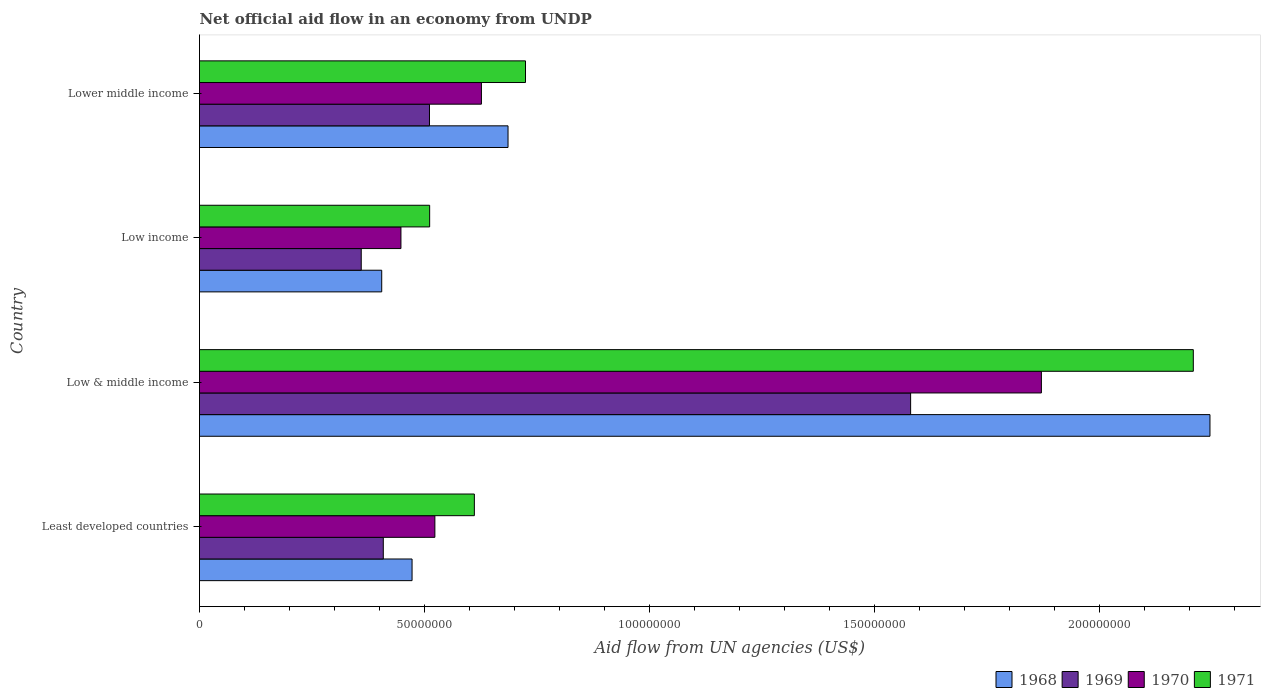How many different coloured bars are there?
Your response must be concise. 4. How many groups of bars are there?
Ensure brevity in your answer.  4. Are the number of bars on each tick of the Y-axis equal?
Ensure brevity in your answer.  Yes. How many bars are there on the 4th tick from the top?
Provide a short and direct response. 4. What is the label of the 1st group of bars from the top?
Offer a terse response. Lower middle income. What is the net official aid flow in 1969 in Lower middle income?
Offer a very short reply. 5.11e+07. Across all countries, what is the maximum net official aid flow in 1971?
Make the answer very short. 2.21e+08. Across all countries, what is the minimum net official aid flow in 1968?
Offer a terse response. 4.05e+07. In which country was the net official aid flow in 1968 maximum?
Provide a succinct answer. Low & middle income. What is the total net official aid flow in 1970 in the graph?
Your answer should be compact. 3.47e+08. What is the difference between the net official aid flow in 1969 in Least developed countries and that in Low & middle income?
Provide a short and direct response. -1.17e+08. What is the difference between the net official aid flow in 1969 in Lower middle income and the net official aid flow in 1968 in Least developed countries?
Provide a short and direct response. 3.87e+06. What is the average net official aid flow in 1969 per country?
Provide a succinct answer. 7.15e+07. What is the difference between the net official aid flow in 1968 and net official aid flow in 1971 in Low income?
Your answer should be very brief. -1.06e+07. What is the ratio of the net official aid flow in 1968 in Least developed countries to that in Low income?
Make the answer very short. 1.17. Is the net official aid flow in 1969 in Least developed countries less than that in Low & middle income?
Give a very brief answer. Yes. Is the difference between the net official aid flow in 1968 in Low income and Lower middle income greater than the difference between the net official aid flow in 1971 in Low income and Lower middle income?
Your response must be concise. No. What is the difference between the highest and the second highest net official aid flow in 1968?
Give a very brief answer. 1.56e+08. What is the difference between the highest and the lowest net official aid flow in 1970?
Provide a succinct answer. 1.42e+08. In how many countries, is the net official aid flow in 1970 greater than the average net official aid flow in 1970 taken over all countries?
Offer a very short reply. 1. Is the sum of the net official aid flow in 1968 in Low income and Lower middle income greater than the maximum net official aid flow in 1970 across all countries?
Provide a succinct answer. No. What does the 1st bar from the top in Least developed countries represents?
Ensure brevity in your answer.  1971. What does the 1st bar from the bottom in Low income represents?
Ensure brevity in your answer.  1968. Is it the case that in every country, the sum of the net official aid flow in 1968 and net official aid flow in 1969 is greater than the net official aid flow in 1971?
Offer a very short reply. Yes. Are all the bars in the graph horizontal?
Give a very brief answer. Yes. How many countries are there in the graph?
Your answer should be very brief. 4. What is the difference between two consecutive major ticks on the X-axis?
Provide a succinct answer. 5.00e+07. Does the graph contain grids?
Give a very brief answer. No. How are the legend labels stacked?
Make the answer very short. Horizontal. What is the title of the graph?
Your answer should be very brief. Net official aid flow in an economy from UNDP. Does "2014" appear as one of the legend labels in the graph?
Ensure brevity in your answer.  No. What is the label or title of the X-axis?
Offer a terse response. Aid flow from UN agencies (US$). What is the label or title of the Y-axis?
Your response must be concise. Country. What is the Aid flow from UN agencies (US$) in 1968 in Least developed countries?
Offer a terse response. 4.72e+07. What is the Aid flow from UN agencies (US$) of 1969 in Least developed countries?
Ensure brevity in your answer.  4.08e+07. What is the Aid flow from UN agencies (US$) in 1970 in Least developed countries?
Offer a terse response. 5.23e+07. What is the Aid flow from UN agencies (US$) of 1971 in Least developed countries?
Your answer should be compact. 6.11e+07. What is the Aid flow from UN agencies (US$) in 1968 in Low & middle income?
Offer a terse response. 2.24e+08. What is the Aid flow from UN agencies (US$) of 1969 in Low & middle income?
Ensure brevity in your answer.  1.58e+08. What is the Aid flow from UN agencies (US$) of 1970 in Low & middle income?
Provide a short and direct response. 1.87e+08. What is the Aid flow from UN agencies (US$) of 1971 in Low & middle income?
Give a very brief answer. 2.21e+08. What is the Aid flow from UN agencies (US$) in 1968 in Low income?
Provide a short and direct response. 4.05e+07. What is the Aid flow from UN agencies (US$) in 1969 in Low income?
Offer a terse response. 3.59e+07. What is the Aid flow from UN agencies (US$) of 1970 in Low income?
Provide a succinct answer. 4.48e+07. What is the Aid flow from UN agencies (US$) of 1971 in Low income?
Your answer should be compact. 5.11e+07. What is the Aid flow from UN agencies (US$) in 1968 in Lower middle income?
Give a very brief answer. 6.85e+07. What is the Aid flow from UN agencies (US$) in 1969 in Lower middle income?
Give a very brief answer. 5.11e+07. What is the Aid flow from UN agencies (US$) in 1970 in Lower middle income?
Give a very brief answer. 6.26e+07. What is the Aid flow from UN agencies (US$) in 1971 in Lower middle income?
Your answer should be compact. 7.24e+07. Across all countries, what is the maximum Aid flow from UN agencies (US$) of 1968?
Provide a succinct answer. 2.24e+08. Across all countries, what is the maximum Aid flow from UN agencies (US$) of 1969?
Your answer should be very brief. 1.58e+08. Across all countries, what is the maximum Aid flow from UN agencies (US$) in 1970?
Offer a terse response. 1.87e+08. Across all countries, what is the maximum Aid flow from UN agencies (US$) of 1971?
Your answer should be very brief. 2.21e+08. Across all countries, what is the minimum Aid flow from UN agencies (US$) of 1968?
Make the answer very short. 4.05e+07. Across all countries, what is the minimum Aid flow from UN agencies (US$) of 1969?
Offer a terse response. 3.59e+07. Across all countries, what is the minimum Aid flow from UN agencies (US$) of 1970?
Your answer should be very brief. 4.48e+07. Across all countries, what is the minimum Aid flow from UN agencies (US$) of 1971?
Make the answer very short. 5.11e+07. What is the total Aid flow from UN agencies (US$) of 1968 in the graph?
Provide a succinct answer. 3.81e+08. What is the total Aid flow from UN agencies (US$) of 1969 in the graph?
Ensure brevity in your answer.  2.86e+08. What is the total Aid flow from UN agencies (US$) in 1970 in the graph?
Provide a succinct answer. 3.47e+08. What is the total Aid flow from UN agencies (US$) of 1971 in the graph?
Your answer should be compact. 4.05e+08. What is the difference between the Aid flow from UN agencies (US$) in 1968 in Least developed countries and that in Low & middle income?
Make the answer very short. -1.77e+08. What is the difference between the Aid flow from UN agencies (US$) of 1969 in Least developed countries and that in Low & middle income?
Your response must be concise. -1.17e+08. What is the difference between the Aid flow from UN agencies (US$) in 1970 in Least developed countries and that in Low & middle income?
Give a very brief answer. -1.35e+08. What is the difference between the Aid flow from UN agencies (US$) of 1971 in Least developed countries and that in Low & middle income?
Provide a short and direct response. -1.60e+08. What is the difference between the Aid flow from UN agencies (US$) of 1968 in Least developed countries and that in Low income?
Offer a terse response. 6.74e+06. What is the difference between the Aid flow from UN agencies (US$) of 1969 in Least developed countries and that in Low income?
Make the answer very short. 4.90e+06. What is the difference between the Aid flow from UN agencies (US$) of 1970 in Least developed countries and that in Low income?
Provide a succinct answer. 7.54e+06. What is the difference between the Aid flow from UN agencies (US$) of 1971 in Least developed countries and that in Low income?
Offer a terse response. 9.93e+06. What is the difference between the Aid flow from UN agencies (US$) of 1968 in Least developed countries and that in Lower middle income?
Provide a short and direct response. -2.13e+07. What is the difference between the Aid flow from UN agencies (US$) in 1969 in Least developed countries and that in Lower middle income?
Give a very brief answer. -1.03e+07. What is the difference between the Aid flow from UN agencies (US$) in 1970 in Least developed countries and that in Lower middle income?
Your answer should be very brief. -1.03e+07. What is the difference between the Aid flow from UN agencies (US$) of 1971 in Least developed countries and that in Lower middle income?
Offer a very short reply. -1.14e+07. What is the difference between the Aid flow from UN agencies (US$) in 1968 in Low & middle income and that in Low income?
Provide a short and direct response. 1.84e+08. What is the difference between the Aid flow from UN agencies (US$) of 1969 in Low & middle income and that in Low income?
Your response must be concise. 1.22e+08. What is the difference between the Aid flow from UN agencies (US$) of 1970 in Low & middle income and that in Low income?
Provide a succinct answer. 1.42e+08. What is the difference between the Aid flow from UN agencies (US$) in 1971 in Low & middle income and that in Low income?
Your response must be concise. 1.70e+08. What is the difference between the Aid flow from UN agencies (US$) in 1968 in Low & middle income and that in Lower middle income?
Offer a terse response. 1.56e+08. What is the difference between the Aid flow from UN agencies (US$) of 1969 in Low & middle income and that in Lower middle income?
Provide a succinct answer. 1.07e+08. What is the difference between the Aid flow from UN agencies (US$) in 1970 in Low & middle income and that in Lower middle income?
Your response must be concise. 1.24e+08. What is the difference between the Aid flow from UN agencies (US$) of 1971 in Low & middle income and that in Lower middle income?
Keep it short and to the point. 1.48e+08. What is the difference between the Aid flow from UN agencies (US$) of 1968 in Low income and that in Lower middle income?
Give a very brief answer. -2.81e+07. What is the difference between the Aid flow from UN agencies (US$) in 1969 in Low income and that in Lower middle income?
Give a very brief answer. -1.52e+07. What is the difference between the Aid flow from UN agencies (US$) in 1970 in Low income and that in Lower middle income?
Offer a terse response. -1.79e+07. What is the difference between the Aid flow from UN agencies (US$) of 1971 in Low income and that in Lower middle income?
Provide a succinct answer. -2.13e+07. What is the difference between the Aid flow from UN agencies (US$) of 1968 in Least developed countries and the Aid flow from UN agencies (US$) of 1969 in Low & middle income?
Provide a short and direct response. -1.11e+08. What is the difference between the Aid flow from UN agencies (US$) in 1968 in Least developed countries and the Aid flow from UN agencies (US$) in 1970 in Low & middle income?
Your answer should be very brief. -1.40e+08. What is the difference between the Aid flow from UN agencies (US$) in 1968 in Least developed countries and the Aid flow from UN agencies (US$) in 1971 in Low & middle income?
Your answer should be very brief. -1.74e+08. What is the difference between the Aid flow from UN agencies (US$) in 1969 in Least developed countries and the Aid flow from UN agencies (US$) in 1970 in Low & middle income?
Your answer should be compact. -1.46e+08. What is the difference between the Aid flow from UN agencies (US$) in 1969 in Least developed countries and the Aid flow from UN agencies (US$) in 1971 in Low & middle income?
Give a very brief answer. -1.80e+08. What is the difference between the Aid flow from UN agencies (US$) in 1970 in Least developed countries and the Aid flow from UN agencies (US$) in 1971 in Low & middle income?
Keep it short and to the point. -1.68e+08. What is the difference between the Aid flow from UN agencies (US$) of 1968 in Least developed countries and the Aid flow from UN agencies (US$) of 1969 in Low income?
Provide a short and direct response. 1.13e+07. What is the difference between the Aid flow from UN agencies (US$) of 1968 in Least developed countries and the Aid flow from UN agencies (US$) of 1970 in Low income?
Your answer should be compact. 2.47e+06. What is the difference between the Aid flow from UN agencies (US$) in 1968 in Least developed countries and the Aid flow from UN agencies (US$) in 1971 in Low income?
Ensure brevity in your answer.  -3.91e+06. What is the difference between the Aid flow from UN agencies (US$) in 1969 in Least developed countries and the Aid flow from UN agencies (US$) in 1970 in Low income?
Your answer should be compact. -3.92e+06. What is the difference between the Aid flow from UN agencies (US$) of 1969 in Least developed countries and the Aid flow from UN agencies (US$) of 1971 in Low income?
Offer a very short reply. -1.03e+07. What is the difference between the Aid flow from UN agencies (US$) of 1970 in Least developed countries and the Aid flow from UN agencies (US$) of 1971 in Low income?
Provide a succinct answer. 1.16e+06. What is the difference between the Aid flow from UN agencies (US$) of 1968 in Least developed countries and the Aid flow from UN agencies (US$) of 1969 in Lower middle income?
Provide a succinct answer. -3.87e+06. What is the difference between the Aid flow from UN agencies (US$) in 1968 in Least developed countries and the Aid flow from UN agencies (US$) in 1970 in Lower middle income?
Make the answer very short. -1.54e+07. What is the difference between the Aid flow from UN agencies (US$) of 1968 in Least developed countries and the Aid flow from UN agencies (US$) of 1971 in Lower middle income?
Provide a short and direct response. -2.52e+07. What is the difference between the Aid flow from UN agencies (US$) of 1969 in Least developed countries and the Aid flow from UN agencies (US$) of 1970 in Lower middle income?
Your response must be concise. -2.18e+07. What is the difference between the Aid flow from UN agencies (US$) of 1969 in Least developed countries and the Aid flow from UN agencies (US$) of 1971 in Lower middle income?
Keep it short and to the point. -3.16e+07. What is the difference between the Aid flow from UN agencies (US$) in 1970 in Least developed countries and the Aid flow from UN agencies (US$) in 1971 in Lower middle income?
Provide a succinct answer. -2.01e+07. What is the difference between the Aid flow from UN agencies (US$) of 1968 in Low & middle income and the Aid flow from UN agencies (US$) of 1969 in Low income?
Offer a very short reply. 1.89e+08. What is the difference between the Aid flow from UN agencies (US$) of 1968 in Low & middle income and the Aid flow from UN agencies (US$) of 1970 in Low income?
Provide a short and direct response. 1.80e+08. What is the difference between the Aid flow from UN agencies (US$) in 1968 in Low & middle income and the Aid flow from UN agencies (US$) in 1971 in Low income?
Provide a short and direct response. 1.73e+08. What is the difference between the Aid flow from UN agencies (US$) of 1969 in Low & middle income and the Aid flow from UN agencies (US$) of 1970 in Low income?
Keep it short and to the point. 1.13e+08. What is the difference between the Aid flow from UN agencies (US$) of 1969 in Low & middle income and the Aid flow from UN agencies (US$) of 1971 in Low income?
Provide a short and direct response. 1.07e+08. What is the difference between the Aid flow from UN agencies (US$) in 1970 in Low & middle income and the Aid flow from UN agencies (US$) in 1971 in Low income?
Give a very brief answer. 1.36e+08. What is the difference between the Aid flow from UN agencies (US$) in 1968 in Low & middle income and the Aid flow from UN agencies (US$) in 1969 in Lower middle income?
Offer a terse response. 1.73e+08. What is the difference between the Aid flow from UN agencies (US$) in 1968 in Low & middle income and the Aid flow from UN agencies (US$) in 1970 in Lower middle income?
Your answer should be very brief. 1.62e+08. What is the difference between the Aid flow from UN agencies (US$) in 1968 in Low & middle income and the Aid flow from UN agencies (US$) in 1971 in Lower middle income?
Your answer should be very brief. 1.52e+08. What is the difference between the Aid flow from UN agencies (US$) in 1969 in Low & middle income and the Aid flow from UN agencies (US$) in 1970 in Lower middle income?
Offer a terse response. 9.54e+07. What is the difference between the Aid flow from UN agencies (US$) in 1969 in Low & middle income and the Aid flow from UN agencies (US$) in 1971 in Lower middle income?
Your answer should be very brief. 8.56e+07. What is the difference between the Aid flow from UN agencies (US$) of 1970 in Low & middle income and the Aid flow from UN agencies (US$) of 1971 in Lower middle income?
Provide a short and direct response. 1.15e+08. What is the difference between the Aid flow from UN agencies (US$) in 1968 in Low income and the Aid flow from UN agencies (US$) in 1969 in Lower middle income?
Your answer should be compact. -1.06e+07. What is the difference between the Aid flow from UN agencies (US$) of 1968 in Low income and the Aid flow from UN agencies (US$) of 1970 in Lower middle income?
Keep it short and to the point. -2.22e+07. What is the difference between the Aid flow from UN agencies (US$) of 1968 in Low income and the Aid flow from UN agencies (US$) of 1971 in Lower middle income?
Offer a very short reply. -3.19e+07. What is the difference between the Aid flow from UN agencies (US$) of 1969 in Low income and the Aid flow from UN agencies (US$) of 1970 in Lower middle income?
Provide a short and direct response. -2.67e+07. What is the difference between the Aid flow from UN agencies (US$) of 1969 in Low income and the Aid flow from UN agencies (US$) of 1971 in Lower middle income?
Your response must be concise. -3.65e+07. What is the difference between the Aid flow from UN agencies (US$) of 1970 in Low income and the Aid flow from UN agencies (US$) of 1971 in Lower middle income?
Provide a short and direct response. -2.77e+07. What is the average Aid flow from UN agencies (US$) of 1968 per country?
Give a very brief answer. 9.52e+07. What is the average Aid flow from UN agencies (US$) of 1969 per country?
Provide a succinct answer. 7.15e+07. What is the average Aid flow from UN agencies (US$) in 1970 per country?
Offer a terse response. 8.67e+07. What is the average Aid flow from UN agencies (US$) of 1971 per country?
Give a very brief answer. 1.01e+08. What is the difference between the Aid flow from UN agencies (US$) in 1968 and Aid flow from UN agencies (US$) in 1969 in Least developed countries?
Offer a very short reply. 6.39e+06. What is the difference between the Aid flow from UN agencies (US$) of 1968 and Aid flow from UN agencies (US$) of 1970 in Least developed countries?
Your response must be concise. -5.07e+06. What is the difference between the Aid flow from UN agencies (US$) in 1968 and Aid flow from UN agencies (US$) in 1971 in Least developed countries?
Give a very brief answer. -1.38e+07. What is the difference between the Aid flow from UN agencies (US$) in 1969 and Aid flow from UN agencies (US$) in 1970 in Least developed countries?
Your answer should be compact. -1.15e+07. What is the difference between the Aid flow from UN agencies (US$) of 1969 and Aid flow from UN agencies (US$) of 1971 in Least developed countries?
Offer a very short reply. -2.02e+07. What is the difference between the Aid flow from UN agencies (US$) in 1970 and Aid flow from UN agencies (US$) in 1971 in Least developed countries?
Offer a very short reply. -8.77e+06. What is the difference between the Aid flow from UN agencies (US$) of 1968 and Aid flow from UN agencies (US$) of 1969 in Low & middle income?
Offer a terse response. 6.65e+07. What is the difference between the Aid flow from UN agencies (US$) in 1968 and Aid flow from UN agencies (US$) in 1970 in Low & middle income?
Offer a very short reply. 3.74e+07. What is the difference between the Aid flow from UN agencies (US$) in 1968 and Aid flow from UN agencies (US$) in 1971 in Low & middle income?
Ensure brevity in your answer.  3.70e+06. What is the difference between the Aid flow from UN agencies (US$) of 1969 and Aid flow from UN agencies (US$) of 1970 in Low & middle income?
Offer a terse response. -2.90e+07. What is the difference between the Aid flow from UN agencies (US$) of 1969 and Aid flow from UN agencies (US$) of 1971 in Low & middle income?
Give a very brief answer. -6.28e+07. What is the difference between the Aid flow from UN agencies (US$) of 1970 and Aid flow from UN agencies (US$) of 1971 in Low & middle income?
Ensure brevity in your answer.  -3.38e+07. What is the difference between the Aid flow from UN agencies (US$) of 1968 and Aid flow from UN agencies (US$) of 1969 in Low income?
Keep it short and to the point. 4.55e+06. What is the difference between the Aid flow from UN agencies (US$) in 1968 and Aid flow from UN agencies (US$) in 1970 in Low income?
Offer a terse response. -4.27e+06. What is the difference between the Aid flow from UN agencies (US$) in 1968 and Aid flow from UN agencies (US$) in 1971 in Low income?
Keep it short and to the point. -1.06e+07. What is the difference between the Aid flow from UN agencies (US$) in 1969 and Aid flow from UN agencies (US$) in 1970 in Low income?
Offer a very short reply. -8.82e+06. What is the difference between the Aid flow from UN agencies (US$) in 1969 and Aid flow from UN agencies (US$) in 1971 in Low income?
Your answer should be very brief. -1.52e+07. What is the difference between the Aid flow from UN agencies (US$) in 1970 and Aid flow from UN agencies (US$) in 1971 in Low income?
Give a very brief answer. -6.38e+06. What is the difference between the Aid flow from UN agencies (US$) in 1968 and Aid flow from UN agencies (US$) in 1969 in Lower middle income?
Ensure brevity in your answer.  1.74e+07. What is the difference between the Aid flow from UN agencies (US$) of 1968 and Aid flow from UN agencies (US$) of 1970 in Lower middle income?
Ensure brevity in your answer.  5.91e+06. What is the difference between the Aid flow from UN agencies (US$) in 1968 and Aid flow from UN agencies (US$) in 1971 in Lower middle income?
Your response must be concise. -3.88e+06. What is the difference between the Aid flow from UN agencies (US$) of 1969 and Aid flow from UN agencies (US$) of 1970 in Lower middle income?
Make the answer very short. -1.15e+07. What is the difference between the Aid flow from UN agencies (US$) of 1969 and Aid flow from UN agencies (US$) of 1971 in Lower middle income?
Give a very brief answer. -2.13e+07. What is the difference between the Aid flow from UN agencies (US$) in 1970 and Aid flow from UN agencies (US$) in 1971 in Lower middle income?
Give a very brief answer. -9.79e+06. What is the ratio of the Aid flow from UN agencies (US$) of 1968 in Least developed countries to that in Low & middle income?
Make the answer very short. 0.21. What is the ratio of the Aid flow from UN agencies (US$) in 1969 in Least developed countries to that in Low & middle income?
Your answer should be very brief. 0.26. What is the ratio of the Aid flow from UN agencies (US$) in 1970 in Least developed countries to that in Low & middle income?
Your answer should be very brief. 0.28. What is the ratio of the Aid flow from UN agencies (US$) in 1971 in Least developed countries to that in Low & middle income?
Your answer should be compact. 0.28. What is the ratio of the Aid flow from UN agencies (US$) of 1968 in Least developed countries to that in Low income?
Keep it short and to the point. 1.17. What is the ratio of the Aid flow from UN agencies (US$) of 1969 in Least developed countries to that in Low income?
Your answer should be compact. 1.14. What is the ratio of the Aid flow from UN agencies (US$) of 1970 in Least developed countries to that in Low income?
Offer a very short reply. 1.17. What is the ratio of the Aid flow from UN agencies (US$) of 1971 in Least developed countries to that in Low income?
Provide a succinct answer. 1.19. What is the ratio of the Aid flow from UN agencies (US$) of 1968 in Least developed countries to that in Lower middle income?
Ensure brevity in your answer.  0.69. What is the ratio of the Aid flow from UN agencies (US$) in 1969 in Least developed countries to that in Lower middle income?
Give a very brief answer. 0.8. What is the ratio of the Aid flow from UN agencies (US$) in 1970 in Least developed countries to that in Lower middle income?
Offer a terse response. 0.83. What is the ratio of the Aid flow from UN agencies (US$) of 1971 in Least developed countries to that in Lower middle income?
Your response must be concise. 0.84. What is the ratio of the Aid flow from UN agencies (US$) in 1968 in Low & middle income to that in Low income?
Offer a very short reply. 5.55. What is the ratio of the Aid flow from UN agencies (US$) of 1969 in Low & middle income to that in Low income?
Give a very brief answer. 4.4. What is the ratio of the Aid flow from UN agencies (US$) in 1970 in Low & middle income to that in Low income?
Your answer should be compact. 4.18. What is the ratio of the Aid flow from UN agencies (US$) of 1971 in Low & middle income to that in Low income?
Offer a terse response. 4.32. What is the ratio of the Aid flow from UN agencies (US$) of 1968 in Low & middle income to that in Lower middle income?
Your answer should be compact. 3.28. What is the ratio of the Aid flow from UN agencies (US$) of 1969 in Low & middle income to that in Lower middle income?
Provide a short and direct response. 3.09. What is the ratio of the Aid flow from UN agencies (US$) in 1970 in Low & middle income to that in Lower middle income?
Keep it short and to the point. 2.99. What is the ratio of the Aid flow from UN agencies (US$) of 1971 in Low & middle income to that in Lower middle income?
Give a very brief answer. 3.05. What is the ratio of the Aid flow from UN agencies (US$) of 1968 in Low income to that in Lower middle income?
Give a very brief answer. 0.59. What is the ratio of the Aid flow from UN agencies (US$) in 1969 in Low income to that in Lower middle income?
Provide a short and direct response. 0.7. What is the ratio of the Aid flow from UN agencies (US$) in 1970 in Low income to that in Lower middle income?
Keep it short and to the point. 0.71. What is the ratio of the Aid flow from UN agencies (US$) in 1971 in Low income to that in Lower middle income?
Keep it short and to the point. 0.71. What is the difference between the highest and the second highest Aid flow from UN agencies (US$) in 1968?
Provide a short and direct response. 1.56e+08. What is the difference between the highest and the second highest Aid flow from UN agencies (US$) of 1969?
Your answer should be very brief. 1.07e+08. What is the difference between the highest and the second highest Aid flow from UN agencies (US$) of 1970?
Provide a short and direct response. 1.24e+08. What is the difference between the highest and the second highest Aid flow from UN agencies (US$) in 1971?
Your response must be concise. 1.48e+08. What is the difference between the highest and the lowest Aid flow from UN agencies (US$) of 1968?
Keep it short and to the point. 1.84e+08. What is the difference between the highest and the lowest Aid flow from UN agencies (US$) of 1969?
Provide a short and direct response. 1.22e+08. What is the difference between the highest and the lowest Aid flow from UN agencies (US$) in 1970?
Ensure brevity in your answer.  1.42e+08. What is the difference between the highest and the lowest Aid flow from UN agencies (US$) in 1971?
Offer a terse response. 1.70e+08. 